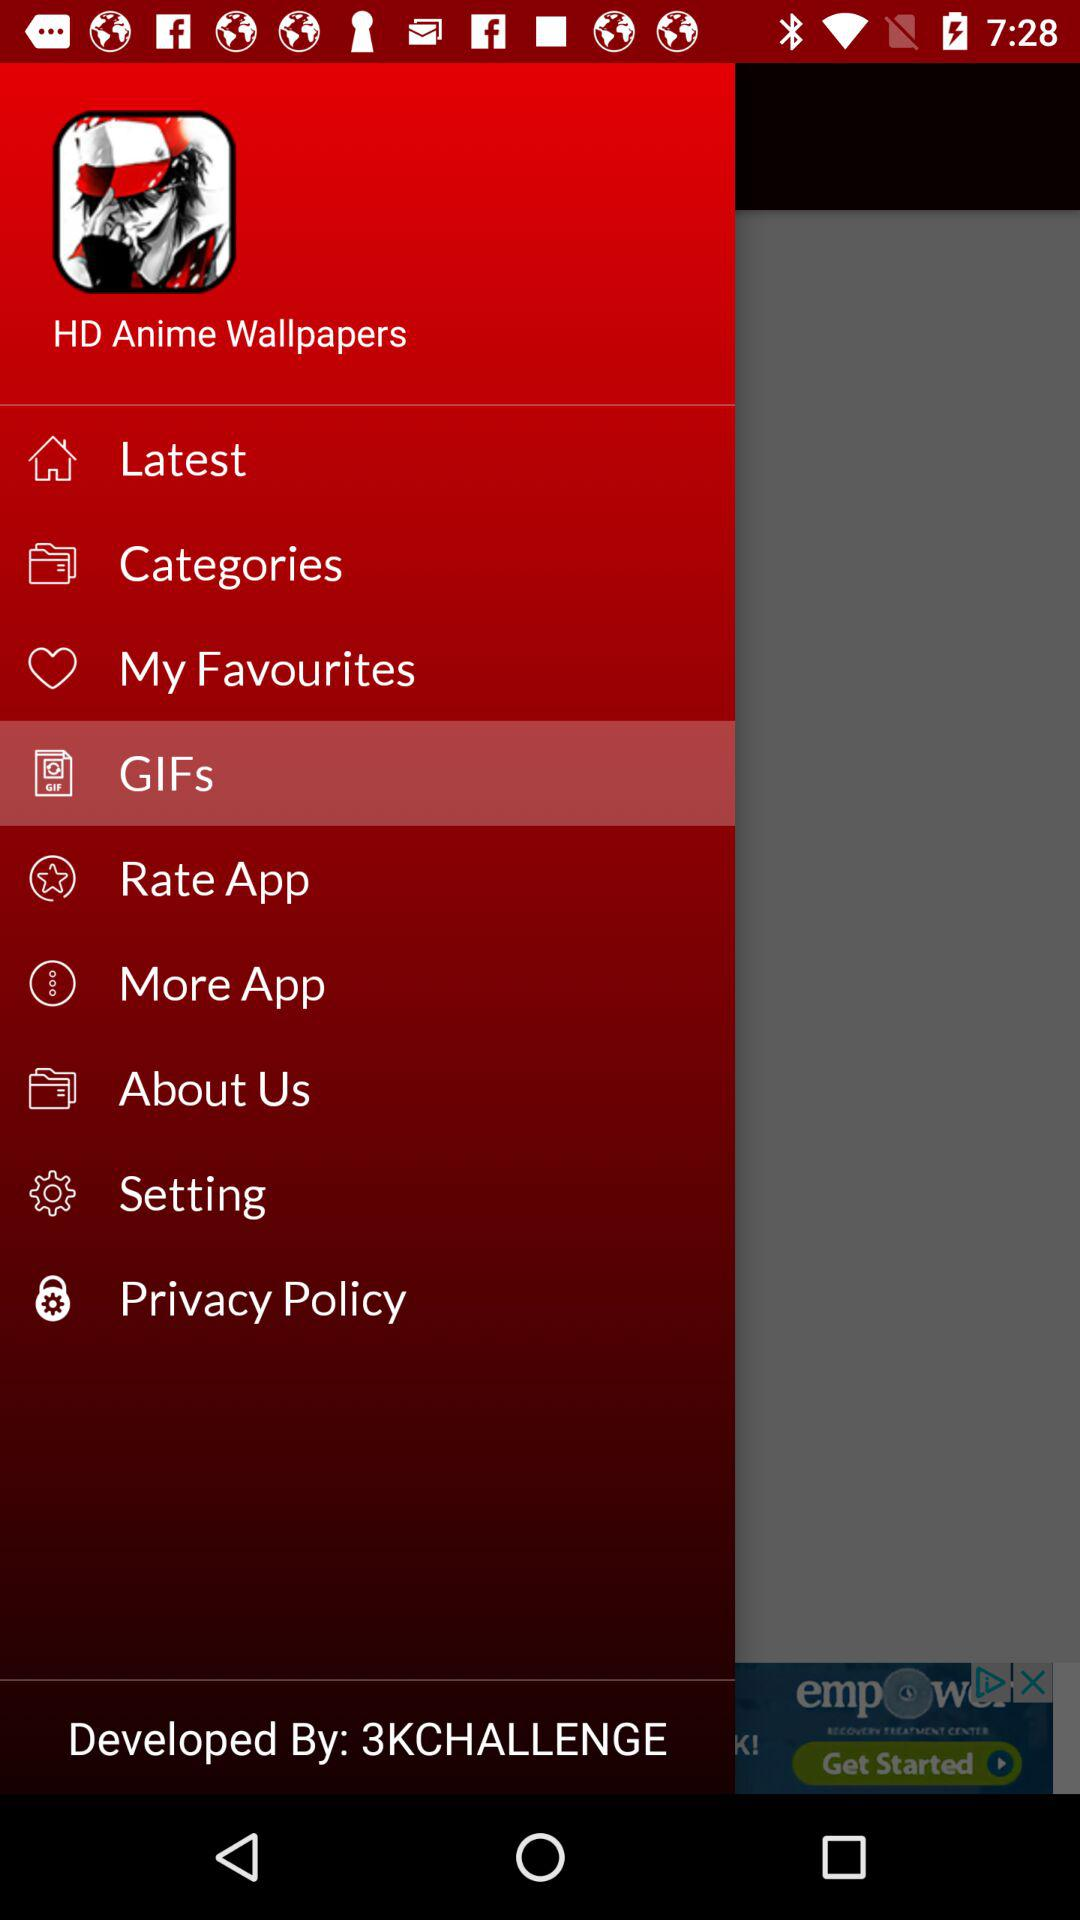Which item is selected? The selected item is "GIFs". 